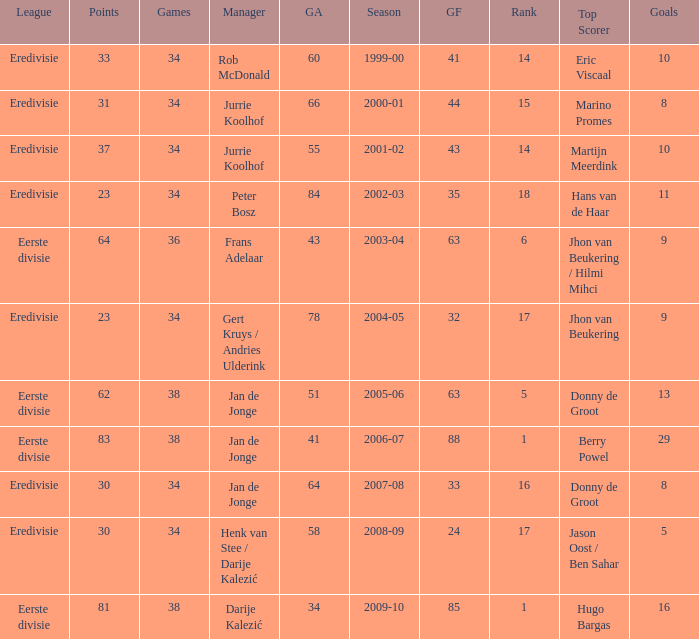Who is the manager whose rank is 16? Jan de Jonge. 